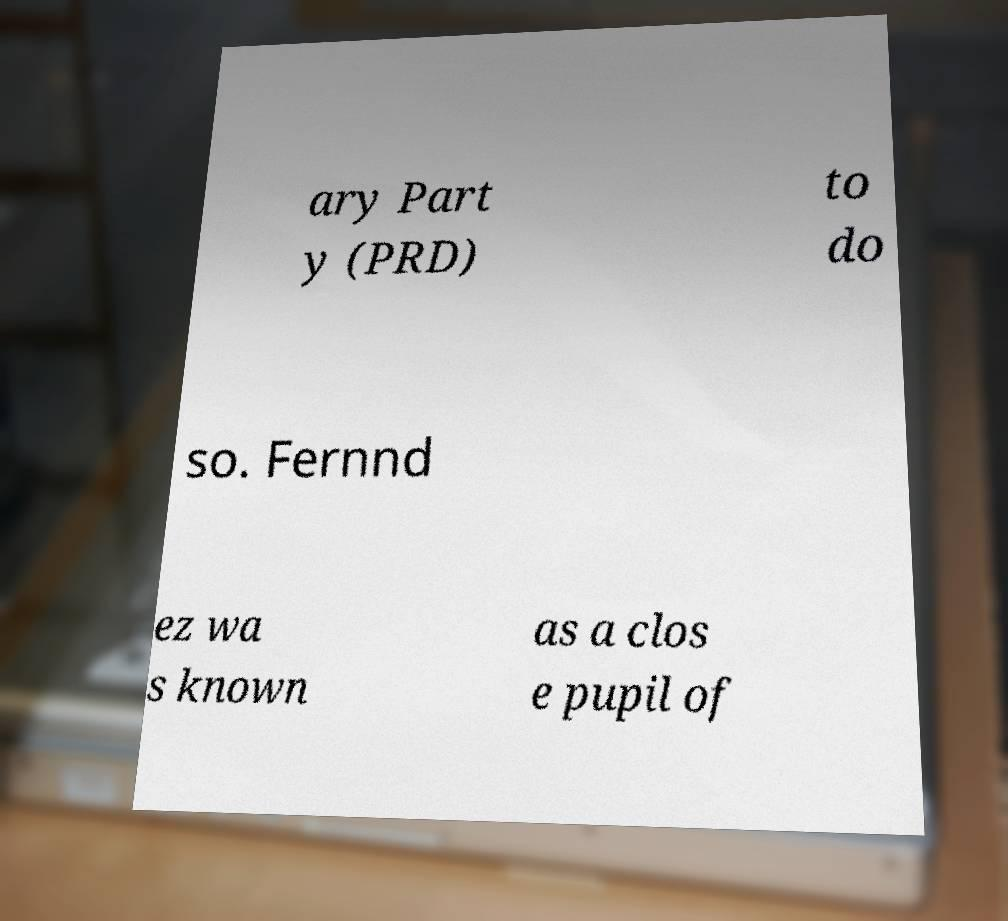Can you accurately transcribe the text from the provided image for me? ary Part y (PRD) to do so. Fernnd ez wa s known as a clos e pupil of 